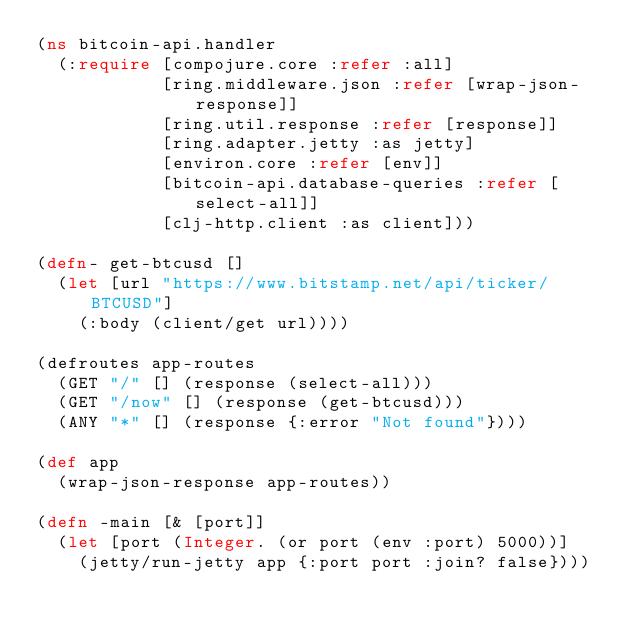Convert code to text. <code><loc_0><loc_0><loc_500><loc_500><_Clojure_>(ns bitcoin-api.handler
  (:require [compojure.core :refer :all]
            [ring.middleware.json :refer [wrap-json-response]]
            [ring.util.response :refer [response]]
            [ring.adapter.jetty :as jetty]
            [environ.core :refer [env]]
            [bitcoin-api.database-queries :refer [select-all]]
            [clj-http.client :as client]))

(defn- get-btcusd []
  (let [url "https://www.bitstamp.net/api/ticker/BTCUSD"]
    (:body (client/get url))))

(defroutes app-routes
  (GET "/" [] (response (select-all)))
  (GET "/now" [] (response (get-btcusd)))
  (ANY "*" [] (response {:error "Not found"})))

(def app
  (wrap-json-response app-routes))

(defn -main [& [port]]
  (let [port (Integer. (or port (env :port) 5000))]
    (jetty/run-jetty app {:port port :join? false})))
</code> 